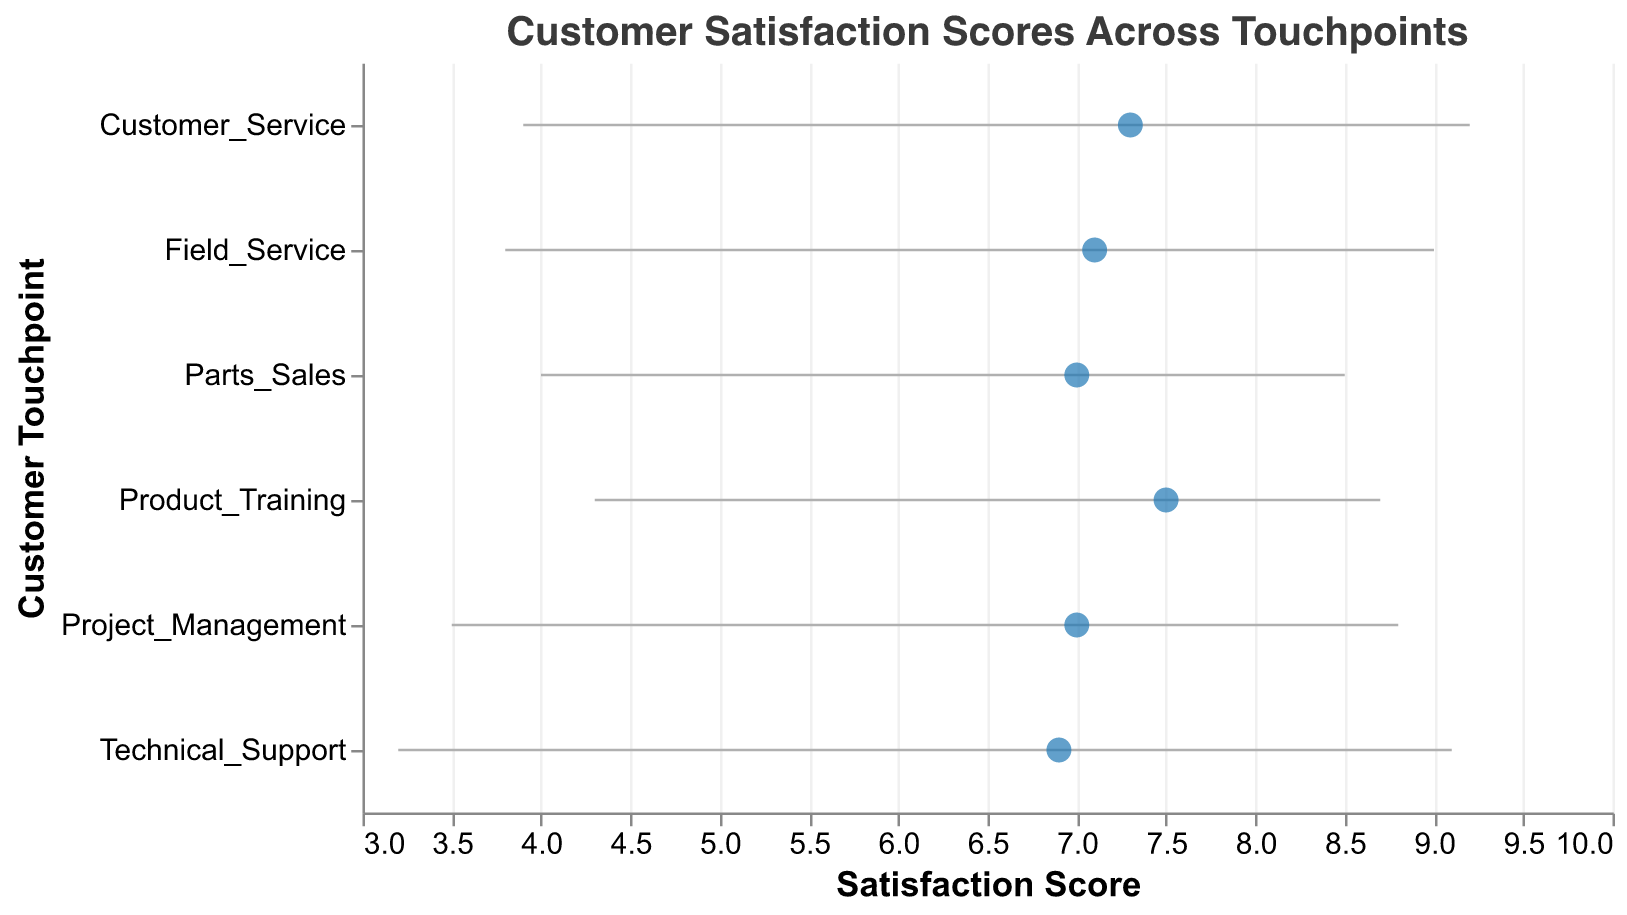What is the mean satisfaction score for Technical Support? The mean satisfaction score is represented by the blue dot corresponding to Technical Support. It is 6.9.
Answer: 6.9 What is the range of satisfaction scores for Field Service? The range of satisfaction scores is from the minimum score to the maximum score for Field Service. It spans from 3.8 to 9.0.
Answer: 3.8 to 9.0 Which touchpoint has the highest maximum satisfaction score? By looking at the right end of the horizontal lines, Customer Service has the highest maximum satisfaction score of 9.2.
Answer: Customer Service Which touchpoint has the smallest range of satisfaction scores? To find the smallest range, calculate the difference between the maximum and minimum scores for each touchpoint. Parts Sales (8.5 - 4.0 = 4.5) has the smallest range.
Answer: Parts Sales What is the difference between the maximum satisfaction scores of Product Training and Technical Support? The maximum satisfaction score for Product Training is 8.7 and for Technical Support is 9.1. The difference is 9.1 - 8.7 = 0.4.
Answer: 0.4 Which touchpoints have a mean satisfaction score of 7.0? The blue dots corresponding to Parts Sales, Project Management, and Field Service show a mean satisfaction score of 7.0.
Answer: Parts Sales, Project Management, Field Service Is the mean satisfaction score for Customer Service higher than that of Technical Support? The mean satisfaction score for Customer Service (7.3) is compared with that for Technical Support (6.9). Yes, 7.3 > 6.9.
Answer: Yes Which touchpoint has the highest mean satisfaction score? By looking at the blue dots, Product Training has the highest mean satisfaction score of 7.5.
Answer: Product Training What is the average of the mean satisfaction scores across all touchpoints? Add up all the mean scores: 6.9 + 7.5 + 7.1 + 7.0 + 7.3 + 7.0 = 42.8. Divide by the number of touchpoints (6): 42.8 / 6 = 7.13.
Answer: 7.13 Which touchpoint has the lowest minimum satisfaction score, and what is it? The horizontal line for Technical Support starts at the lowest score of 3.2.
Answer: Technical Support, 3.2 